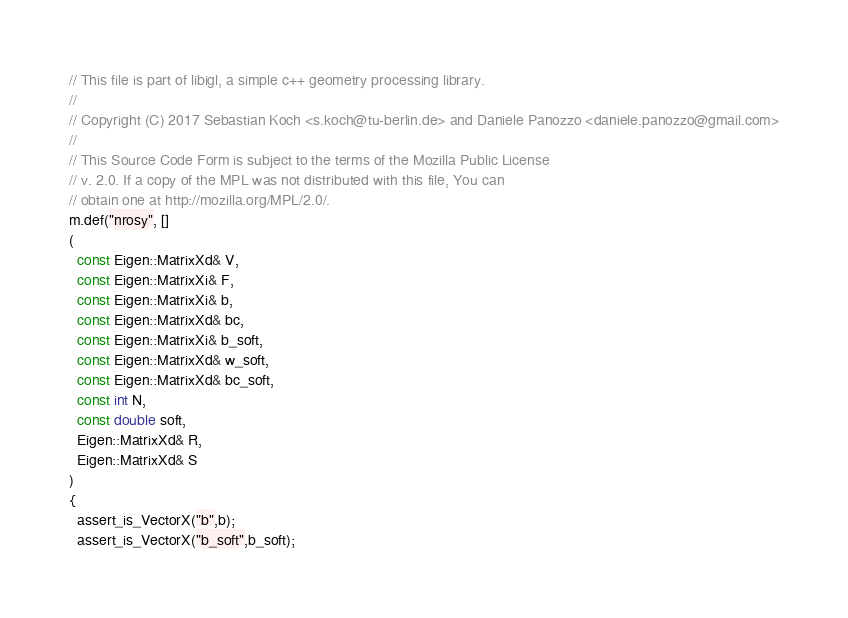<code> <loc_0><loc_0><loc_500><loc_500><_C++_>// This file is part of libigl, a simple c++ geometry processing library.
//
// Copyright (C) 2017 Sebastian Koch <s.koch@tu-berlin.de> and Daniele Panozzo <daniele.panozzo@gmail.com>
//
// This Source Code Form is subject to the terms of the Mozilla Public License
// v. 2.0. If a copy of the MPL was not distributed with this file, You can
// obtain one at http://mozilla.org/MPL/2.0/.
m.def("nrosy", []
(
  const Eigen::MatrixXd& V,
  const Eigen::MatrixXi& F,
  const Eigen::MatrixXi& b,
  const Eigen::MatrixXd& bc,
  const Eigen::MatrixXi& b_soft,
  const Eigen::MatrixXd& w_soft,
  const Eigen::MatrixXd& bc_soft,
  const int N,
  const double soft,
  Eigen::MatrixXd& R,
  Eigen::MatrixXd& S
)
{
  assert_is_VectorX("b",b);
  assert_is_VectorX("b_soft",b_soft);</code> 